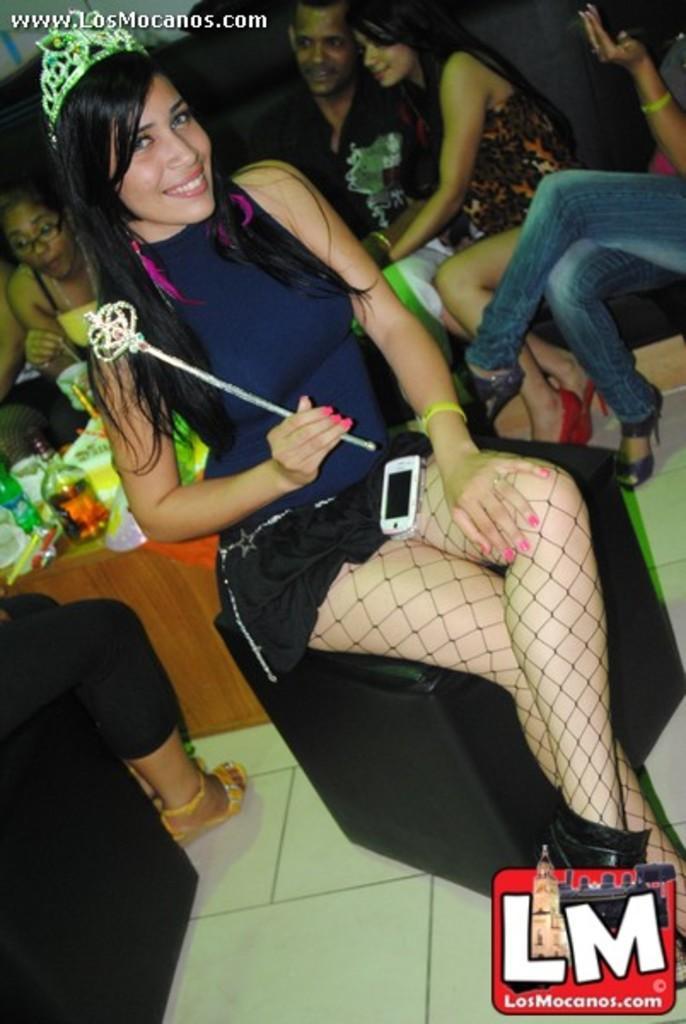Please provide a concise description of this image. The woman in front of the picture is holding a stick in her hand and she is sitting on the stool. She is smiling and she is posing for the photo. She is wearing the crown. Behind her, we see people are sitting on the sofa. In front of them, we see a table on which water bottle, glass bottle, cups and a cake are placed. This picture might be clicked in the room. 